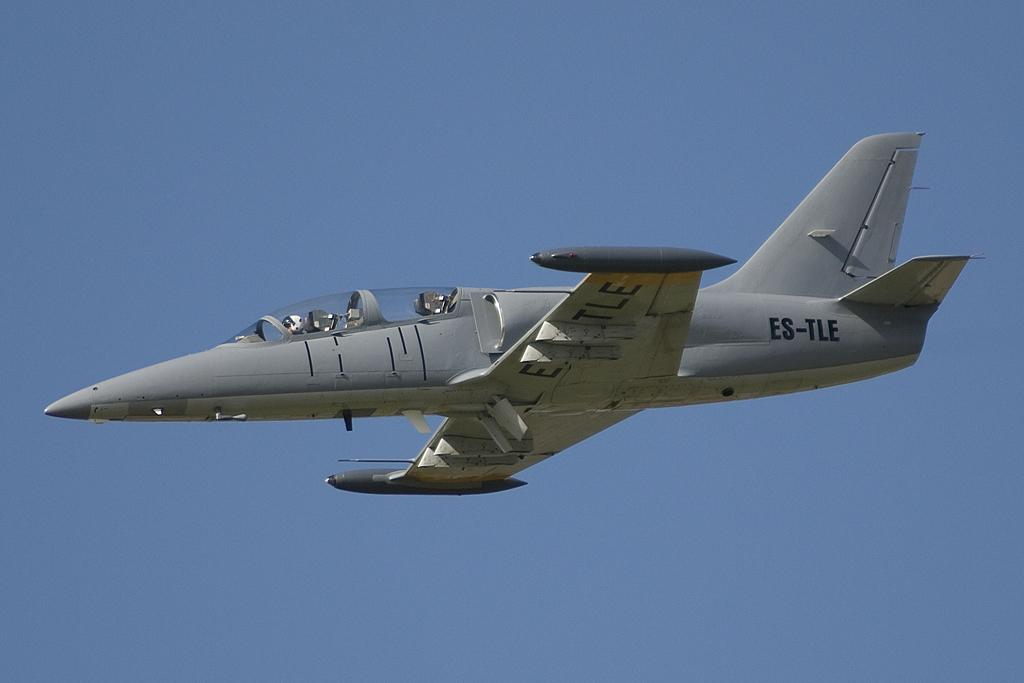What is the main subject of the image? The main subject of the image is an aeroplane. What is the aeroplane doing in the image? The aeroplane is flying in the air. What can be seen in the background of the image? There is sky visible in the background of the image. What shape is the paper that the aeroplane is made of in the image? There is no paper mentioned in the image, and the aeroplane is not made of paper. 